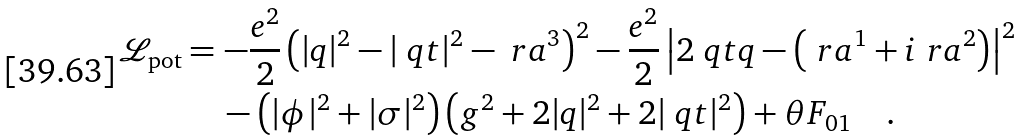<formula> <loc_0><loc_0><loc_500><loc_500>\mathcal { L } _ { \text {pot} } & = - \frac { e ^ { 2 } } { 2 } \left ( | q | ^ { 2 } - | \ q t | ^ { 2 } - \ r a ^ { 3 } \right ) ^ { 2 } - \frac { e ^ { 2 } } { 2 } \left | 2 \ q t q - \left ( \ r a ^ { 1 } + i \ r a ^ { 2 } \right ) \right | ^ { 2 } \\ & \quad \, - \left ( | \phi | ^ { 2 } + | \sigma | ^ { 2 } \right ) \left ( g ^ { 2 } + 2 | q | ^ { 2 } + 2 | \ q t | ^ { 2 } \right ) + \theta F _ { 0 1 } \quad .</formula> 